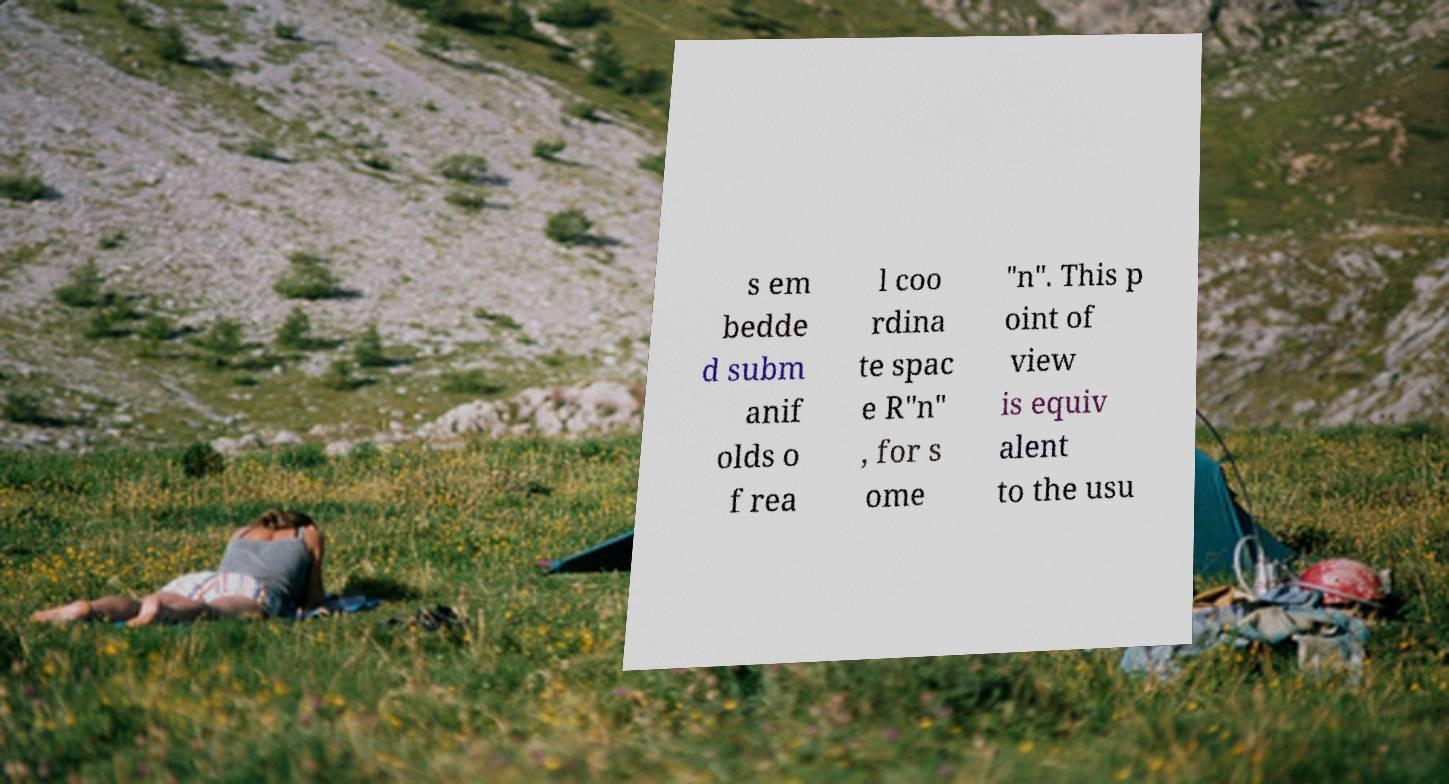Could you extract and type out the text from this image? s em bedde d subm anif olds o f rea l coo rdina te spac e R"n" , for s ome "n". This p oint of view is equiv alent to the usu 